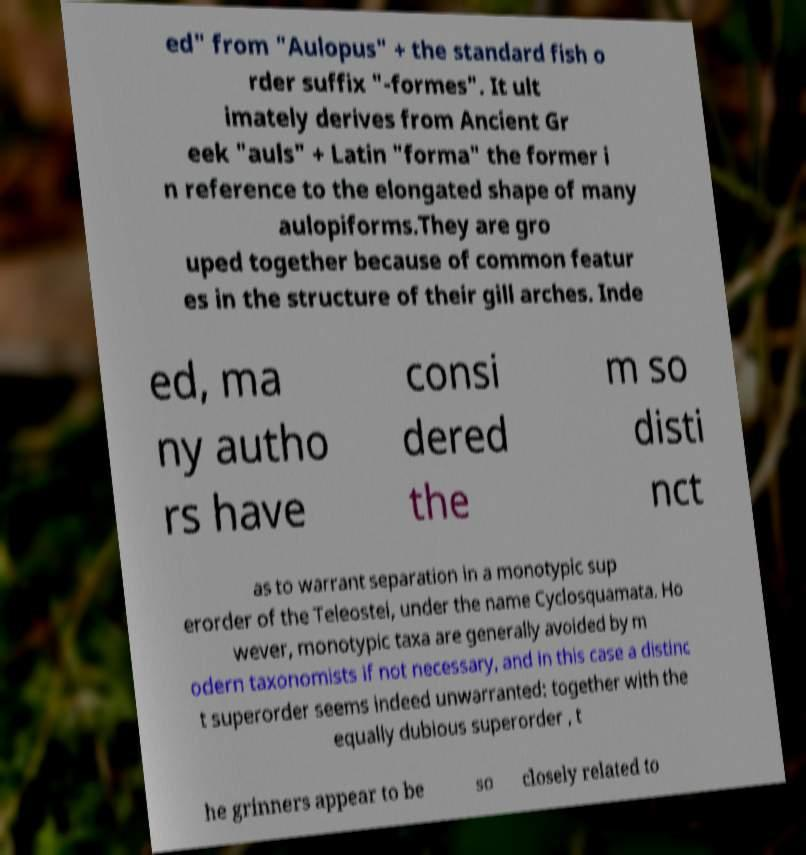I need the written content from this picture converted into text. Can you do that? ed" from "Aulopus" + the standard fish o rder suffix "-formes". It ult imately derives from Ancient Gr eek "auls" + Latin "forma" the former i n reference to the elongated shape of many aulopiforms.They are gro uped together because of common featur es in the structure of their gill arches. Inde ed, ma ny autho rs have consi dered the m so disti nct as to warrant separation in a monotypic sup erorder of the Teleostei, under the name Cyclosquamata. Ho wever, monotypic taxa are generally avoided by m odern taxonomists if not necessary, and in this case a distinc t superorder seems indeed unwarranted: together with the equally dubious superorder , t he grinners appear to be so closely related to 